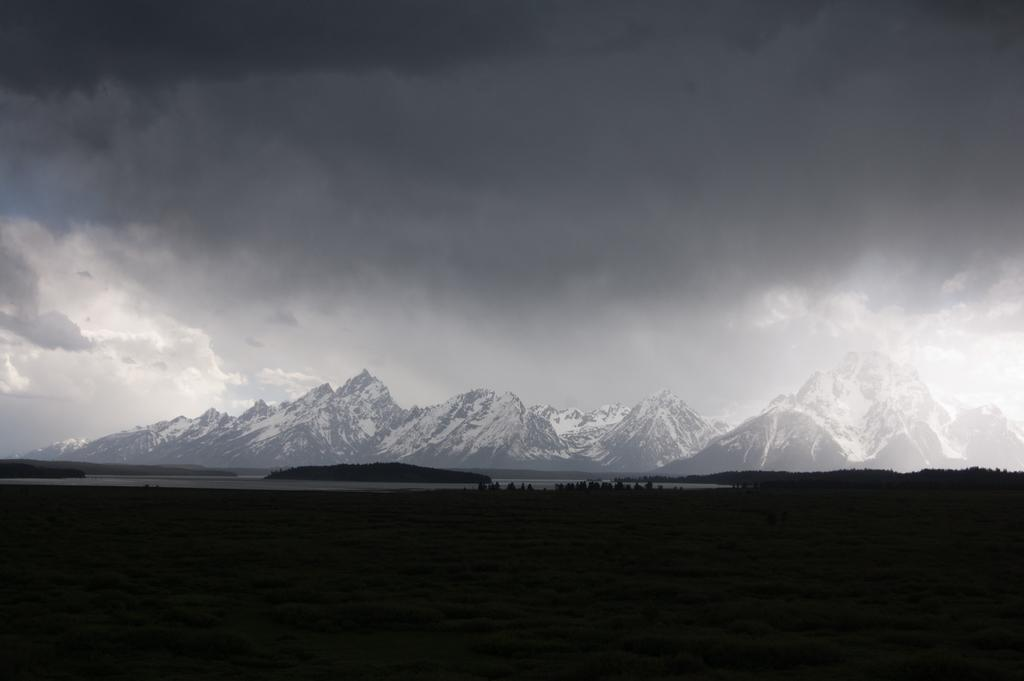What type of vegetation is present in the image? There are trees in the image. What type of geographical feature can be seen in the image? There are snowy mountains in the image. What is visible in the background of the image? The sky is visible in the background of the image. How many frogs can be seen in the image? There are no frogs present in the image. What is the aftermath of the event depicted in the image? There is no event depicted in the image, so there is no aftermath to discuss. 